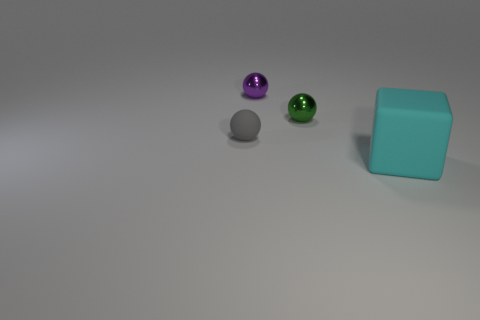Subtract all red cubes. Subtract all purple cylinders. How many cubes are left? 1 Add 1 metal things. How many objects exist? 5 Subtract all balls. How many objects are left? 1 Subtract 0 blue cubes. How many objects are left? 4 Subtract all big matte cubes. Subtract all cyan matte cubes. How many objects are left? 2 Add 1 large things. How many large things are left? 2 Add 3 large red balls. How many large red balls exist? 3 